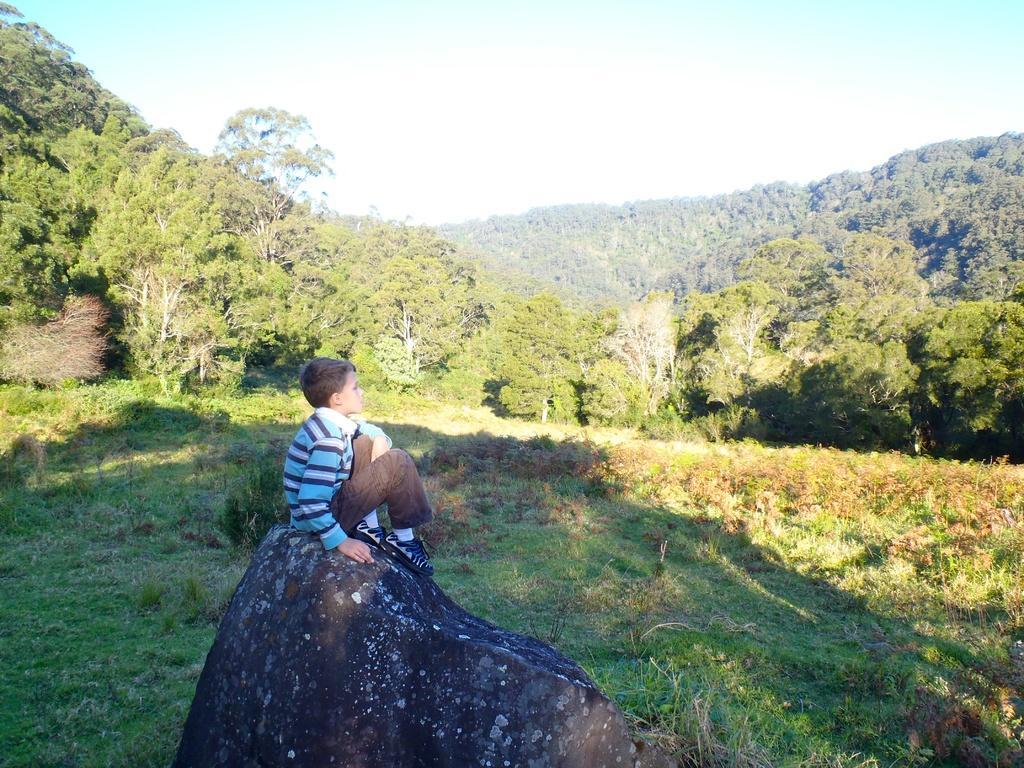Describe this image in one or two sentences. There is a boy sitting on a rock. On the ground there are plants. In the back there are trees and sky. 